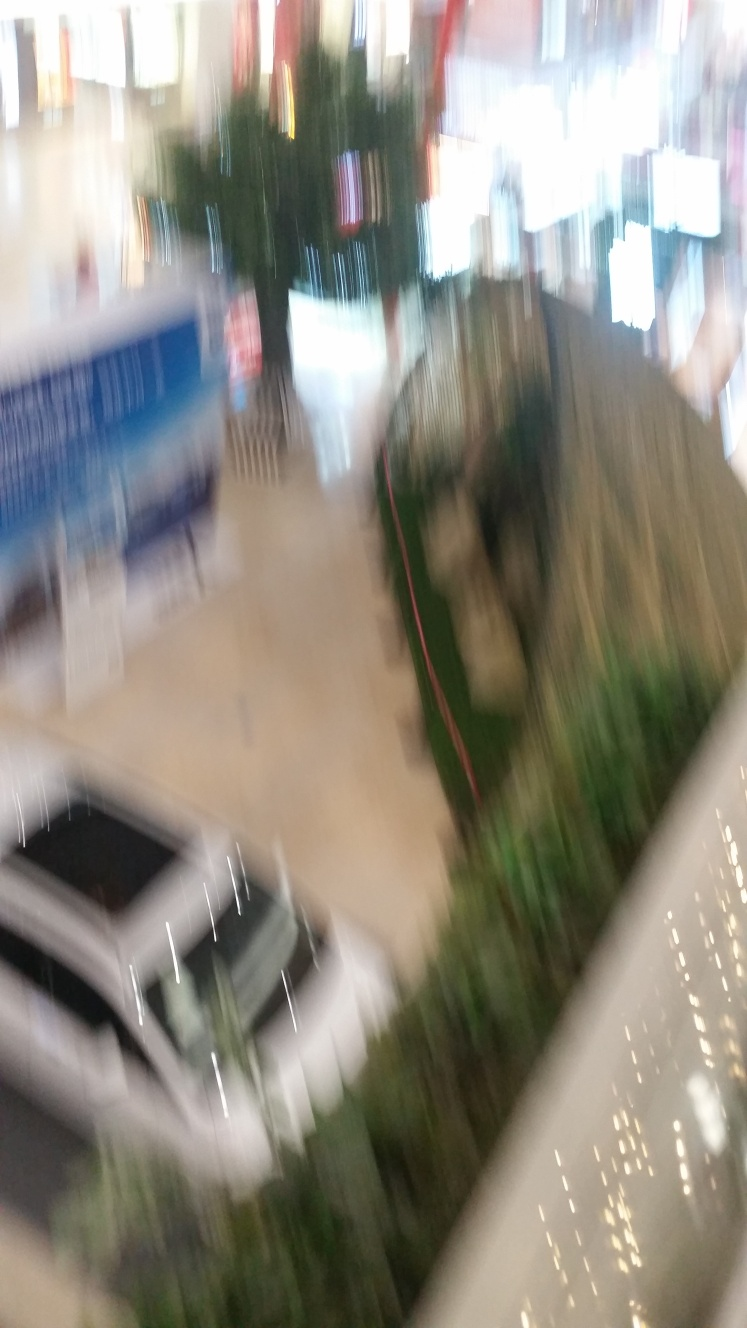What might have caused the blurriness in this photo? The blurriness in the photo is likely due to the camera moving significantly during the capture process or a slow shutter speed, which didn't freeze the motion in the frame. 